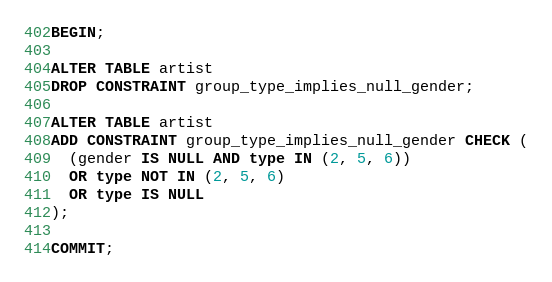Convert code to text. <code><loc_0><loc_0><loc_500><loc_500><_SQL_>BEGIN;

ALTER TABLE artist
DROP CONSTRAINT group_type_implies_null_gender;

ALTER TABLE artist
ADD CONSTRAINT group_type_implies_null_gender CHECK (
  (gender IS NULL AND type IN (2, 5, 6))
  OR type NOT IN (2, 5, 6)
  OR type IS NULL
);

COMMIT;
</code> 